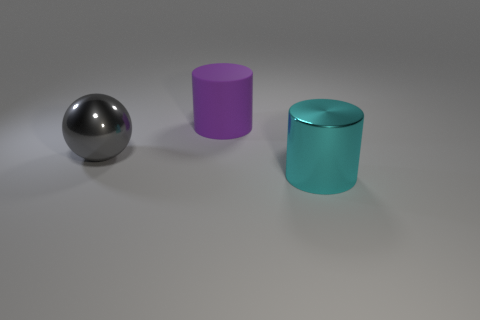Add 3 large cyan shiny cylinders. How many objects exist? 6 Subtract all cylinders. How many objects are left? 1 Add 2 balls. How many balls are left? 3 Add 3 red metal balls. How many red metal balls exist? 3 Subtract all purple cylinders. How many cylinders are left? 1 Subtract 0 cyan blocks. How many objects are left? 3 Subtract 1 spheres. How many spheres are left? 0 Subtract all green cylinders. Subtract all blue cubes. How many cylinders are left? 2 Subtract all red balls. How many gray cylinders are left? 0 Subtract all purple matte cubes. Subtract all large gray balls. How many objects are left? 2 